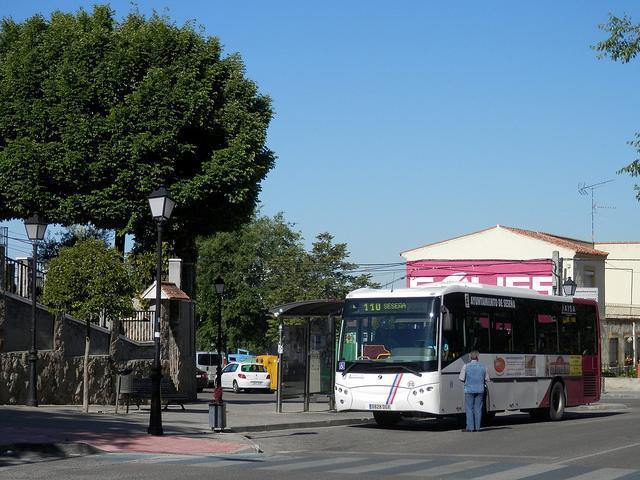How many buses are there?
Give a very brief answer. 1. How many levels does the bus have?
Give a very brief answer. 1. How many stripes are crossing the street?
Give a very brief answer. 6. How many levels does this bus have?
Give a very brief answer. 1. How many buses?
Give a very brief answer. 1. 